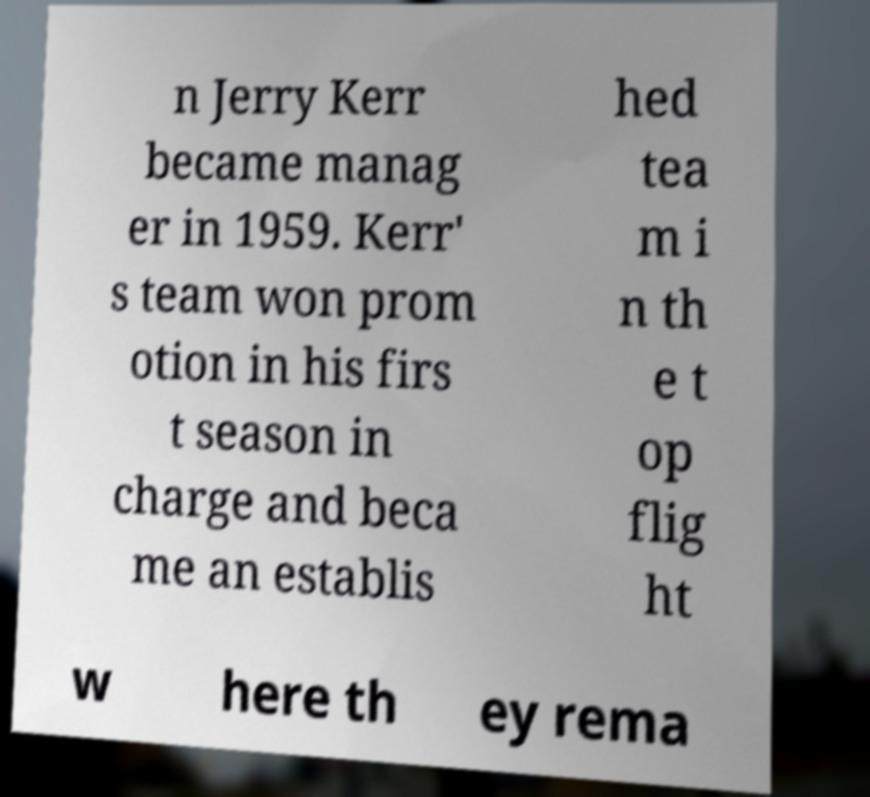What messages or text are displayed in this image? I need them in a readable, typed format. n Jerry Kerr became manag er in 1959. Kerr' s team won prom otion in his firs t season in charge and beca me an establis hed tea m i n th e t op flig ht w here th ey rema 